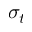Convert formula to latex. <formula><loc_0><loc_0><loc_500><loc_500>\sigma _ { t }</formula> 